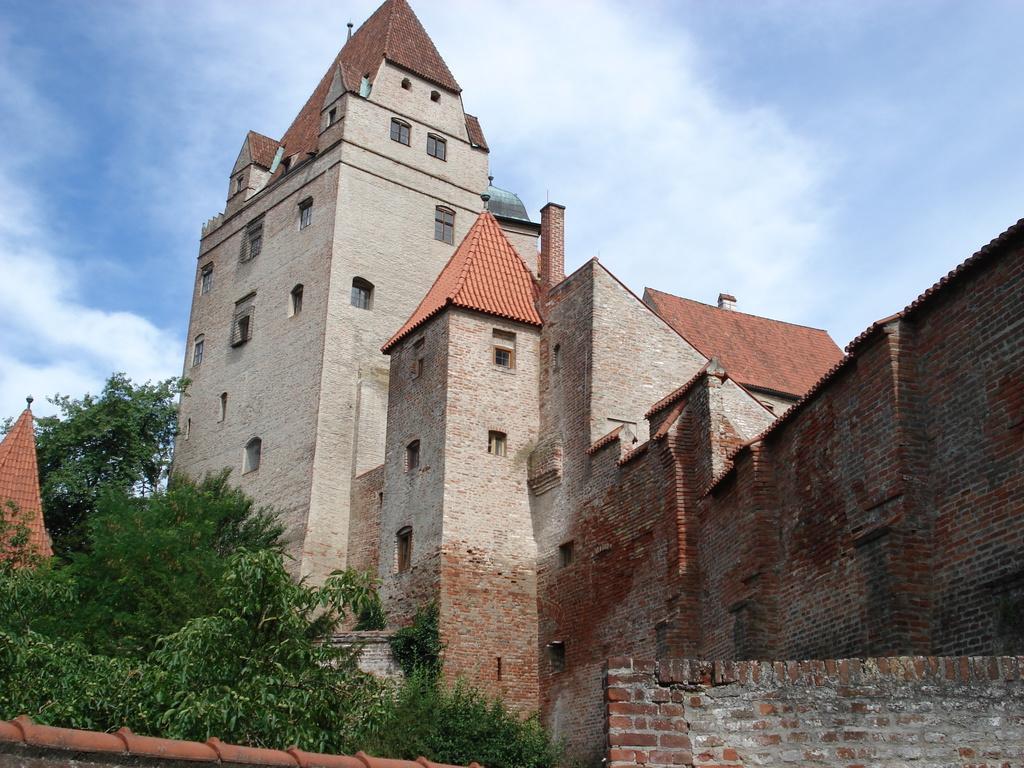How would you summarize this image in a sentence or two? In this image there are trees, compound wall, buildings , and in the background there is sky. 